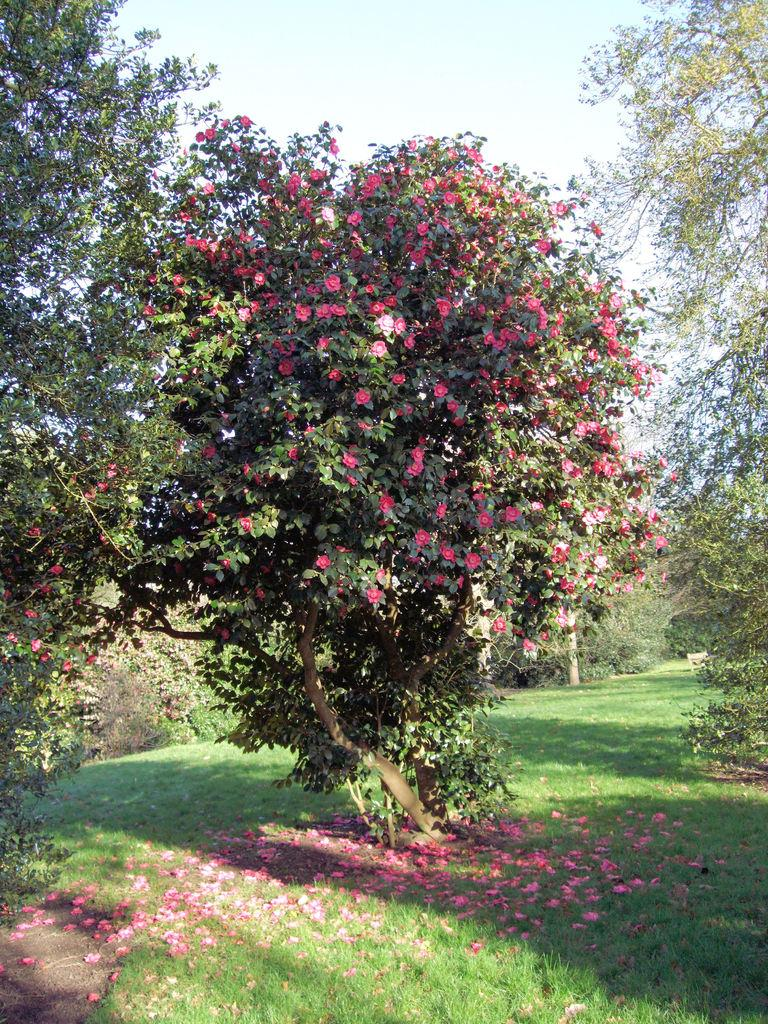What type of vegetation can be seen in the image? There are trees in the image. What other natural elements are present on the ground in the image? There are flowers on the grass in the image. What is visible at the top of the image? The sky is visible at the top of the image. What type of fear is depicted in the image? There is no fear depicted in the image; it features trees, flowers, grass, and the sky. How does the image provide comfort to the viewer? The image itself does not provide comfort to the viewer, as it is a static representation of natural elements. 